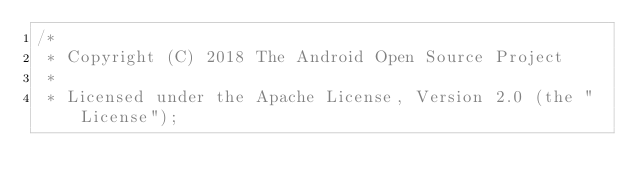<code> <loc_0><loc_0><loc_500><loc_500><_Java_>/*
 * Copyright (C) 2018 The Android Open Source Project
 *
 * Licensed under the Apache License, Version 2.0 (the "License");</code> 